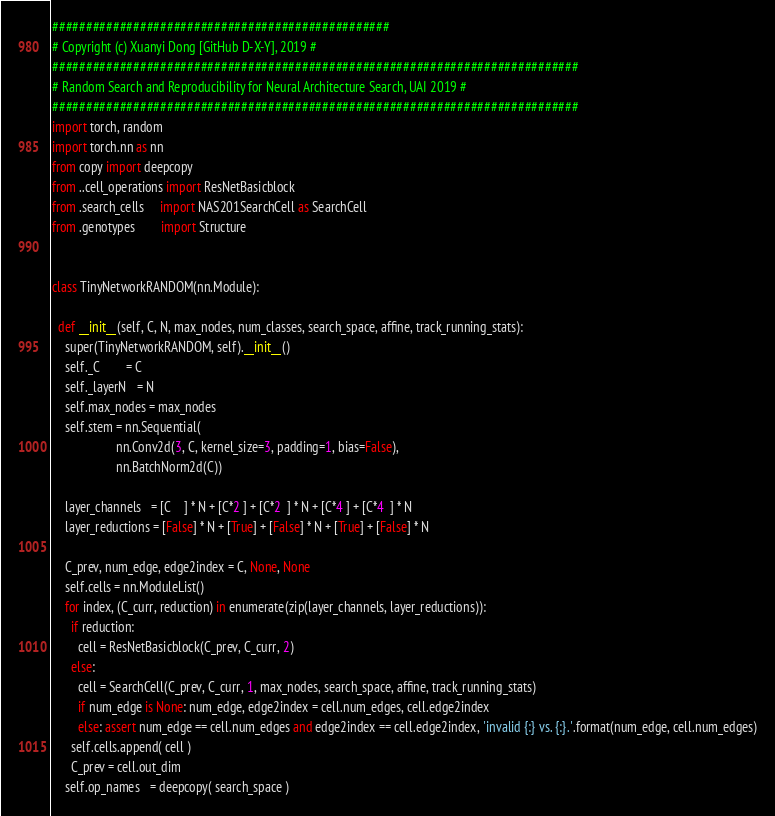Convert code to text. <code><loc_0><loc_0><loc_500><loc_500><_Python_>##################################################
# Copyright (c) Xuanyi Dong [GitHub D-X-Y], 2019 #
##############################################################################
# Random Search and Reproducibility for Neural Architecture Search, UAI 2019 # 
##############################################################################
import torch, random
import torch.nn as nn
from copy import deepcopy
from ..cell_operations import ResNetBasicblock
from .search_cells     import NAS201SearchCell as SearchCell
from .genotypes        import Structure


class TinyNetworkRANDOM(nn.Module):

  def __init__(self, C, N, max_nodes, num_classes, search_space, affine, track_running_stats):
    super(TinyNetworkRANDOM, self).__init__()
    self._C        = C
    self._layerN   = N
    self.max_nodes = max_nodes
    self.stem = nn.Sequential(
                    nn.Conv2d(3, C, kernel_size=3, padding=1, bias=False),
                    nn.BatchNorm2d(C))
  
    layer_channels   = [C    ] * N + [C*2 ] + [C*2  ] * N + [C*4 ] + [C*4  ] * N    
    layer_reductions = [False] * N + [True] + [False] * N + [True] + [False] * N

    C_prev, num_edge, edge2index = C, None, None
    self.cells = nn.ModuleList()
    for index, (C_curr, reduction) in enumerate(zip(layer_channels, layer_reductions)):
      if reduction:
        cell = ResNetBasicblock(C_prev, C_curr, 2)
      else:
        cell = SearchCell(C_prev, C_curr, 1, max_nodes, search_space, affine, track_running_stats)
        if num_edge is None: num_edge, edge2index = cell.num_edges, cell.edge2index
        else: assert num_edge == cell.num_edges and edge2index == cell.edge2index, 'invalid {:} vs. {:}.'.format(num_edge, cell.num_edges)
      self.cells.append( cell )
      C_prev = cell.out_dim
    self.op_names   = deepcopy( search_space )</code> 